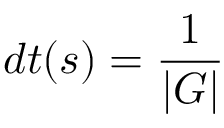<formula> <loc_0><loc_0><loc_500><loc_500>d t ( s ) = { \frac { 1 } { | G | } }</formula> 